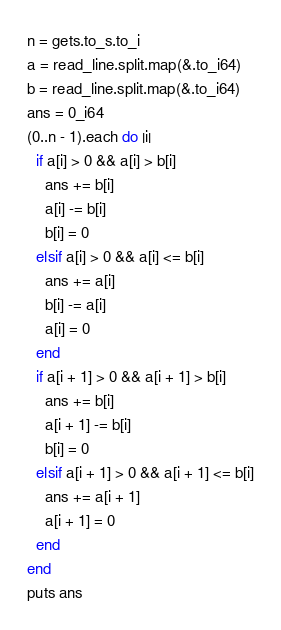Convert code to text. <code><loc_0><loc_0><loc_500><loc_500><_Crystal_>n = gets.to_s.to_i
a = read_line.split.map(&.to_i64)
b = read_line.split.map(&.to_i64)
ans = 0_i64
(0..n - 1).each do |i|
  if a[i] > 0 && a[i] > b[i]
    ans += b[i]
    a[i] -= b[i]
    b[i] = 0
  elsif a[i] > 0 && a[i] <= b[i]
    ans += a[i]
    b[i] -= a[i]
    a[i] = 0
  end
  if a[i + 1] > 0 && a[i + 1] > b[i]
    ans += b[i]
    a[i + 1] -= b[i]
    b[i] = 0
  elsif a[i + 1] > 0 && a[i + 1] <= b[i]
    ans += a[i + 1]
    a[i + 1] = 0
  end
end
puts ans</code> 